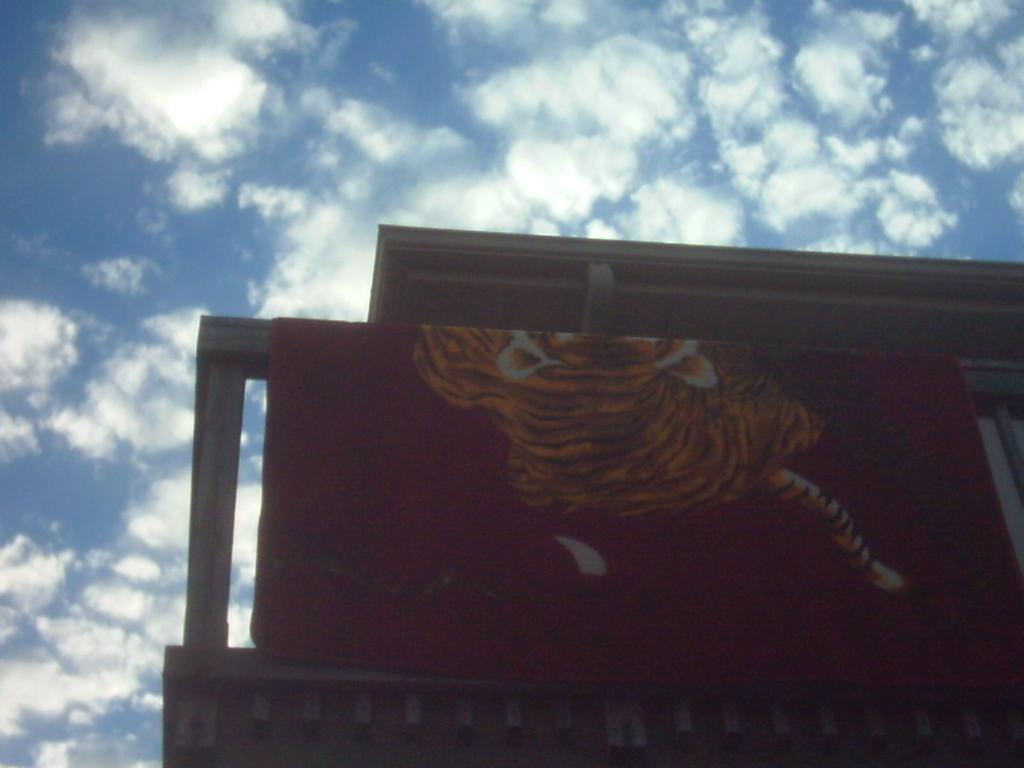What type of structure is present in the image? There is a building in the image. What is covering part of the building? There is a cloth on the building. What can be seen in the background of the image? There are clouds visible in the background of the image. What color is the sky in the background of the image? The sky is blue in the background of the image. How does the machine work in the image? There is no machine present in the image; it features a building with a cloth on it and clouds in the background. 